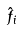Convert formula to latex. <formula><loc_0><loc_0><loc_500><loc_500>\hat { f } _ { i }</formula> 